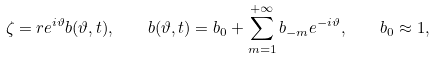Convert formula to latex. <formula><loc_0><loc_0><loc_500><loc_500>\zeta = r e ^ { i \vartheta } b ( \vartheta , t ) , \quad b ( \vartheta , t ) = b _ { 0 } + \sum _ { m = 1 } ^ { + \infty } b _ { - m } e ^ { - i \vartheta } , \quad b _ { 0 } \approx 1 ,</formula> 